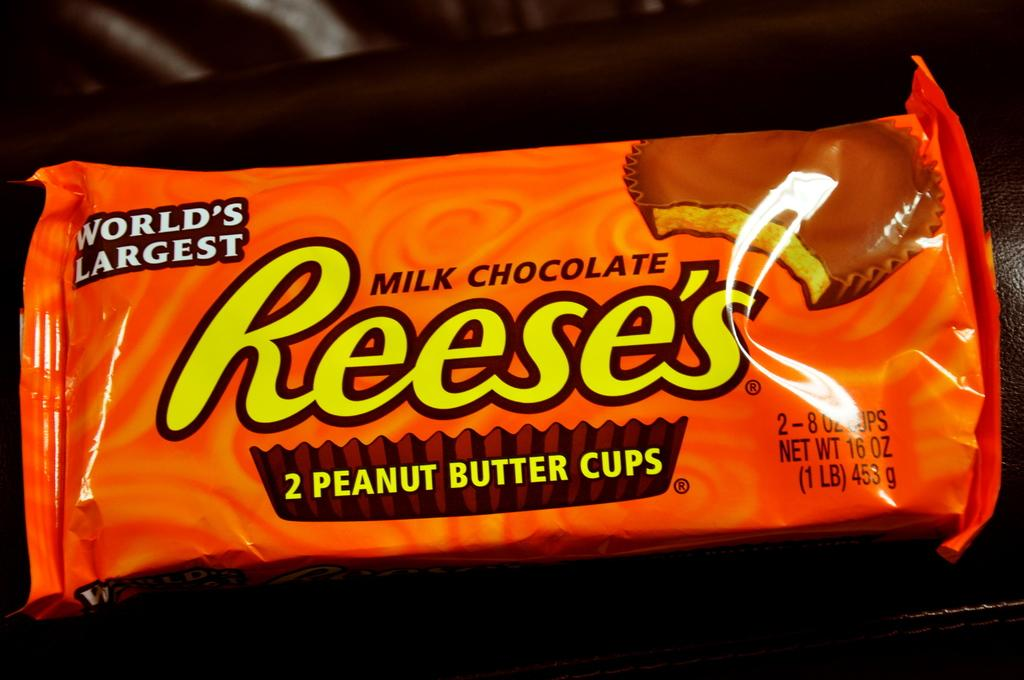<image>
Summarize the visual content of the image. an unopened package of Reese's peanut butter cups 